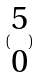Convert formula to latex. <formula><loc_0><loc_0><loc_500><loc_500>( \begin{matrix} 5 \\ 0 \end{matrix} )</formula> 